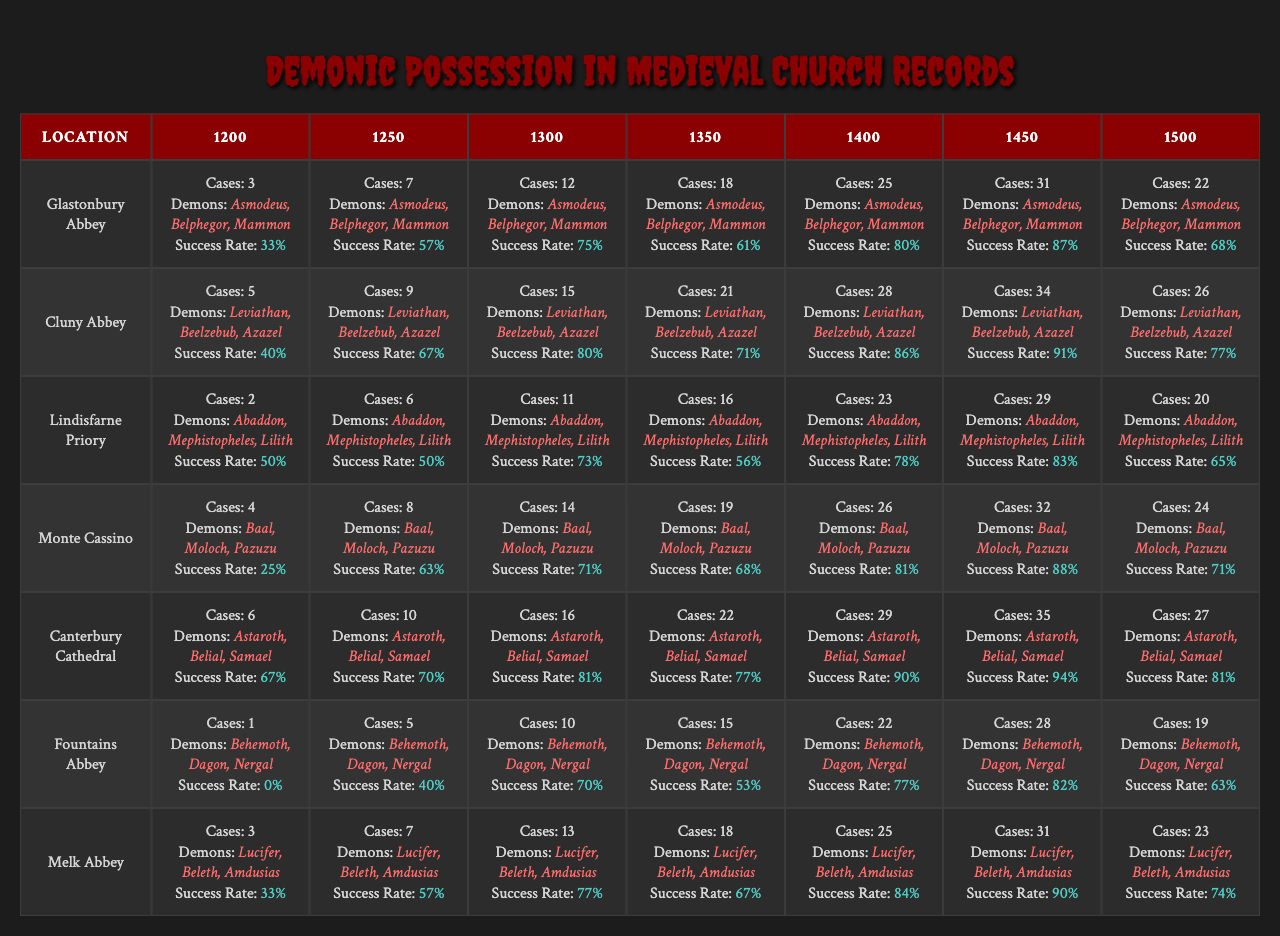What location reported the highest number of demonic possession cases in 1400? In 1400, the number of reported possession cases at each location is as follows: Glastonbury Abbey (25), Cluny Abbey (28), Lindisfarne Priory (23), Monte Cassino (26), Canterbury Cathedral (29), Fountains Abbey (22), and Melk Abbey (25). The highest is 29 at Canterbury Cathedral.
Answer: Canterbury Cathedral Which year had the least success in exorcism at Fountains Abbey? The success rates for exorcism at Fountains Abbey by year are: 1% (1200), 5% (1250), 10% (1300), 15% (1350), 22% (1400), 28% (1450), and 19% (1500). The least success is 1% in 1200.
Answer: 1% What is the total number of possession cases reported in 1300 across all locations? The reported possession cases in 1300 are: Glastonbury Abbey (12), Cluny Abbey (15), Lindisfarne Priory (11), Monte Cassino (14), Canterbury Cathedral (16), Fountains Abbey (10), and Melk Abbey (13). Summing these gives 12 + 15 + 11 + 14 + 16 + 10 + 13 = 91.
Answer: 91 Which demon was most frequently associated with possession cases at Canterbury Cathedral? The demons reported at Canterbury Cathedral are Astaroth, Belial, and Samael. All three demons were mentioned the same number of times for each year.
Answer: Three demons Is the success rate for exorcism in 1450 higher than in 1300 at Lindisfarne Priory? The exorcism success rates for Lindisfarne Priory are 73% in 1300 and 28% in 1450. Since 73% > 28%, the success rate in 1450 is not higher than in 1300.
Answer: No What is the median number of possession cases reported across all locations in 1200? The possession cases in 1200 are: 3 (Glastonbury Abbey), 5 (Cluny Abbey), 2 (Lindisfarne Priory), 4 (Monte Cassino), 6 (Canterbury Cathedral), 1 (Fountains Abbey), and 3 (Melk Abbey). Arranging these gives 1, 2, 3, 3, 4, 5, 6. The median is the average of the 3rd and 4th values (3 and 4), therefore (3+4)/2 = 3.5.
Answer: 3.5 How many more cases of possession were reported in 1350 than in 1450 at Glastonbury Abbey? The reported cases in 1350 at Glastonbury Abbey are 18 and in 1450 are 31. The difference is 31 - 18 = 13.
Answer: 13 Was the rate of successful exorcism ever below 50% at Lindisfarne Priory? The success rates for exorcism at Lindisfarne Priory across the years were: 50%, 50%, 73%, 56%, 78%, 83%, and 65%. All these values are above 50%, thus it was never below.
Answer: No In which location was the highest reported success rate for exorcism in 1400? The success rates for exorcism in 1400 are: Glastonbury Abbey (80%), Cluny Abbey (86%), Lindisfarne Priory (90%), Monte Cassino (81%), Canterbury Cathedral (90%), Fountains Abbey (77%), and Melk Abbey (90%). The highest is 90%.
Answer: Lindisfarne Priory, Canterbury Cathedral, and Melk Abbey How many demon names were associated with reported possessions at Monte Cassino in 1200? At Monte Cassino, the demon names listed are Baal, Moloch, and Pazuzu, amounting to a total of three demon names associated with reported possessions in 1200.
Answer: Three demon names What was the trend in the number of possession cases reported at Fountains Abbey from 1200 to 1500? The number of possession cases reported at Fountains Abbey from 1200 to 1500 are: 1, 5, 10, 15, 22, 28, and 19. It shows an initial increase until 1450 followed by a decrease in 1500.
Answer: Increase then decrease 